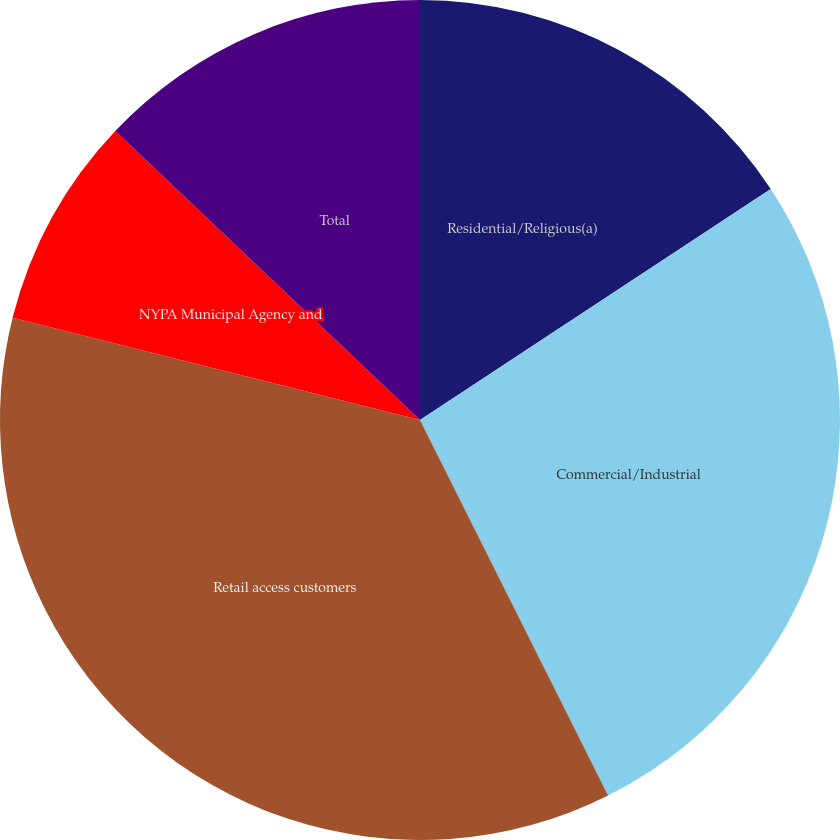Convert chart. <chart><loc_0><loc_0><loc_500><loc_500><pie_chart><fcel>Residential/Religious(a)<fcel>Commercial/Industrial<fcel>Retail access customers<fcel>NYPA Municipal Agency and<fcel>Total<nl><fcel>15.73%<fcel>26.88%<fcel>36.3%<fcel>8.17%<fcel>12.92%<nl></chart> 